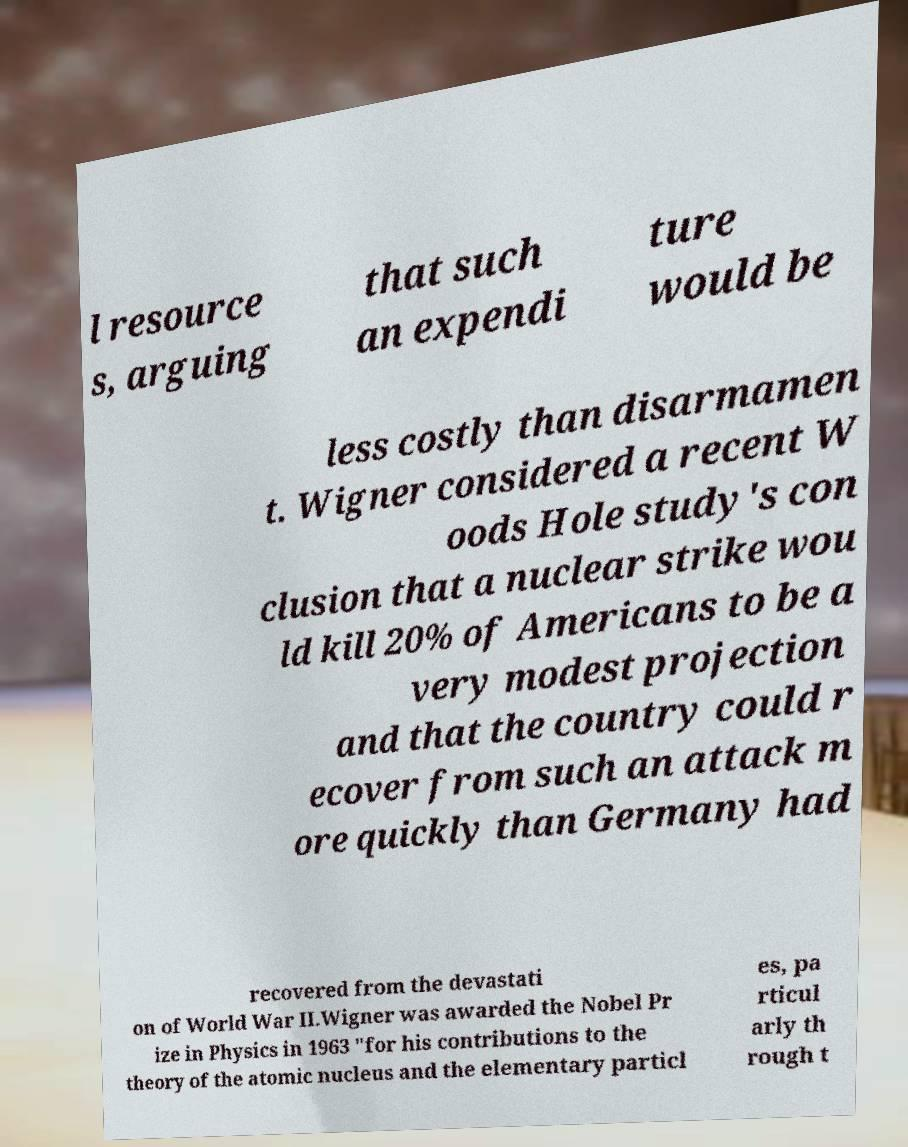Could you extract and type out the text from this image? l resource s, arguing that such an expendi ture would be less costly than disarmamen t. Wigner considered a recent W oods Hole study's con clusion that a nuclear strike wou ld kill 20% of Americans to be a very modest projection and that the country could r ecover from such an attack m ore quickly than Germany had recovered from the devastati on of World War II.Wigner was awarded the Nobel Pr ize in Physics in 1963 "for his contributions to the theory of the atomic nucleus and the elementary particl es, pa rticul arly th rough t 